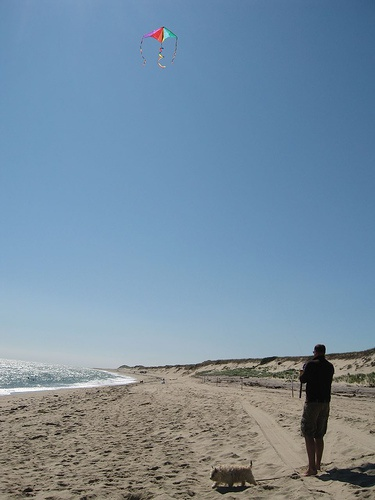Describe the objects in this image and their specific colors. I can see people in gray, black, and darkgray tones, dog in gray, black, and darkgray tones, and kite in gray, teal, salmon, lightblue, and brown tones in this image. 